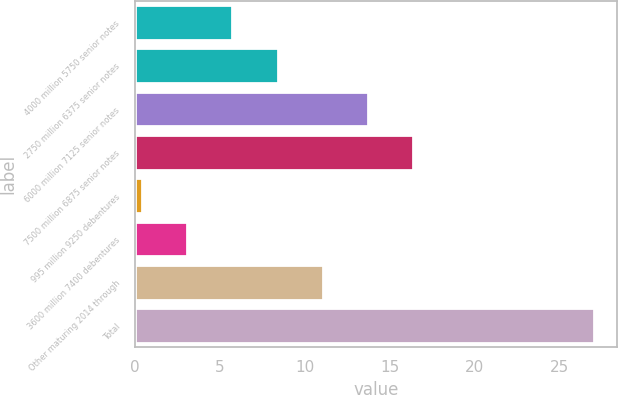<chart> <loc_0><loc_0><loc_500><loc_500><bar_chart><fcel>4000 million 5750 senior notes<fcel>2750 million 6375 senior notes<fcel>6000 million 7125 senior notes<fcel>7500 million 6875 senior notes<fcel>995 million 9250 debentures<fcel>3600 million 7400 debentures<fcel>Other maturing 2014 through<fcel>Total<nl><fcel>5.72<fcel>8.38<fcel>13.7<fcel>16.36<fcel>0.4<fcel>3.06<fcel>11.04<fcel>27<nl></chart> 